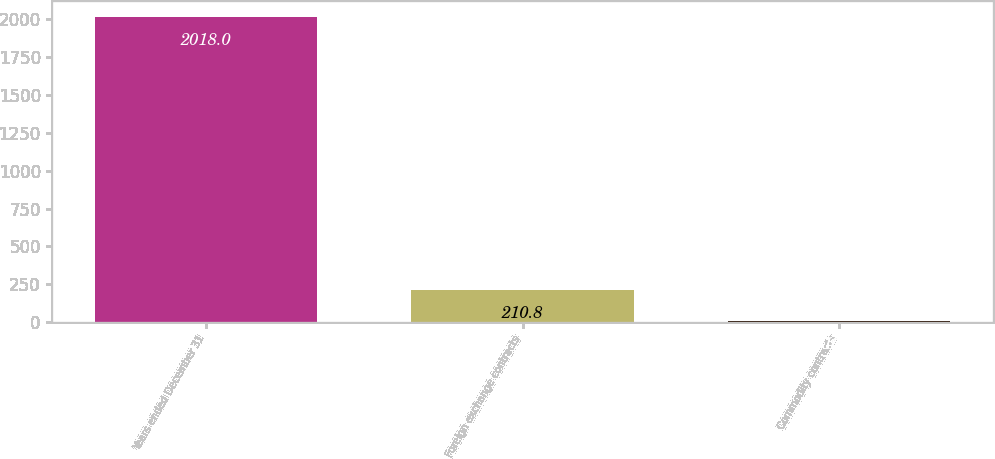<chart> <loc_0><loc_0><loc_500><loc_500><bar_chart><fcel>Years ended December 31<fcel>Foreign exchange contracts<fcel>Commodity contracts<nl><fcel>2018<fcel>210.8<fcel>10<nl></chart> 